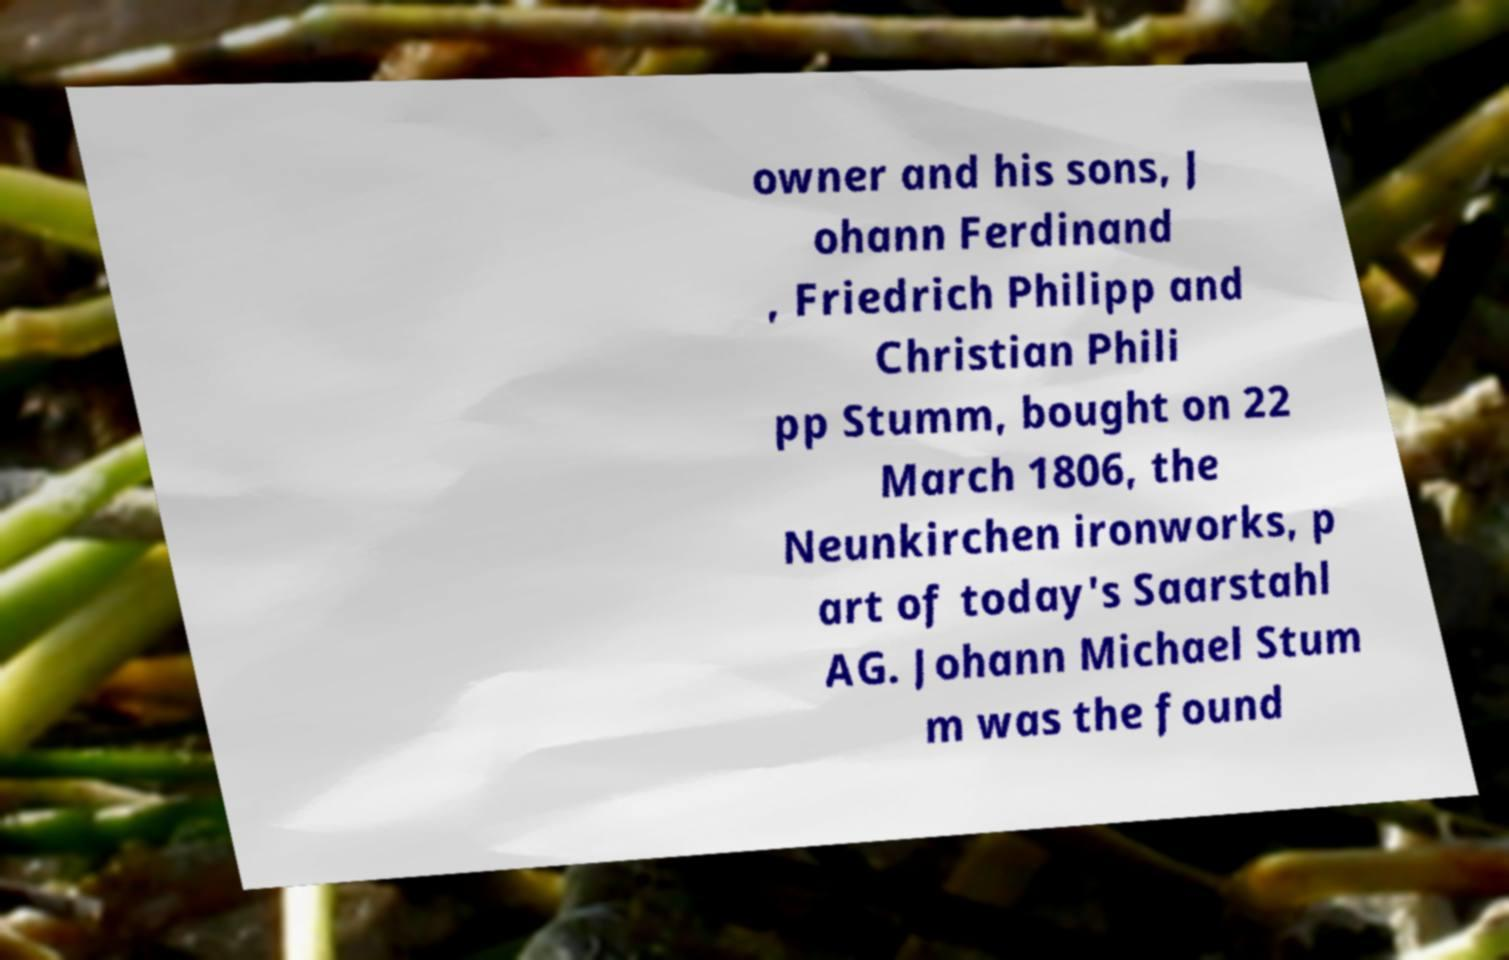Can you read and provide the text displayed in the image?This photo seems to have some interesting text. Can you extract and type it out for me? owner and his sons, J ohann Ferdinand , Friedrich Philipp and Christian Phili pp Stumm, bought on 22 March 1806, the Neunkirchen ironworks, p art of today's Saarstahl AG. Johann Michael Stum m was the found 